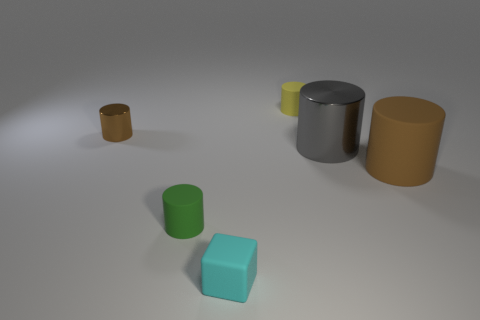Is the big rubber thing the same color as the tiny shiny object?
Give a very brief answer. Yes. The big cylinder that is made of the same material as the small yellow cylinder is what color?
Give a very brief answer. Brown. Do the tiny metallic cylinder and the matte cylinder on the right side of the tiny yellow rubber cylinder have the same color?
Make the answer very short. Yes. There is a small thing that is both to the left of the rubber cube and in front of the gray metal object; what color is it?
Provide a short and direct response. Green. How many gray cylinders are behind the green matte thing?
Give a very brief answer. 1. How many things are large brown cylinders or small cylinders to the left of the tiny cyan rubber object?
Your answer should be compact. 3. There is a thing behind the brown shiny cylinder; are there any objects that are left of it?
Give a very brief answer. Yes. There is a tiny rubber object behind the brown metallic thing; what color is it?
Keep it short and to the point. Yellow. Is the number of matte blocks that are behind the large matte cylinder the same as the number of tiny yellow things?
Your response must be concise. No. The small thing that is both right of the green cylinder and in front of the big gray shiny object has what shape?
Offer a terse response. Cube. 